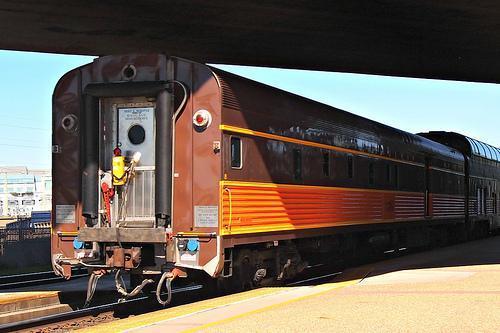How many people are running near the train?
Give a very brief answer. 0. 